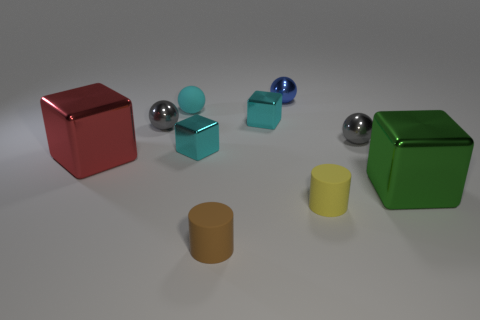What is the size of the other rubber object that is the same shape as the tiny brown matte thing?
Offer a terse response. Small. The object that is in front of the yellow thing behind the small brown cylinder is what shape?
Your response must be concise. Cylinder. What number of yellow objects are small rubber things or large things?
Offer a terse response. 1. Is the size of the green object the same as the brown matte object?
Make the answer very short. No. Is there any other thing that has the same shape as the blue metallic object?
Give a very brief answer. Yes. Is the small brown thing made of the same material as the tiny gray sphere that is left of the tiny brown matte thing?
Ensure brevity in your answer.  No. Is the color of the big metal thing behind the green object the same as the matte ball?
Provide a short and direct response. No. What number of small rubber things are on the left side of the small yellow thing and in front of the green object?
Your answer should be very brief. 1. How many other objects are there of the same material as the large red block?
Offer a terse response. 6. Is the tiny cyan thing that is right of the brown matte thing made of the same material as the tiny blue sphere?
Your response must be concise. Yes. 